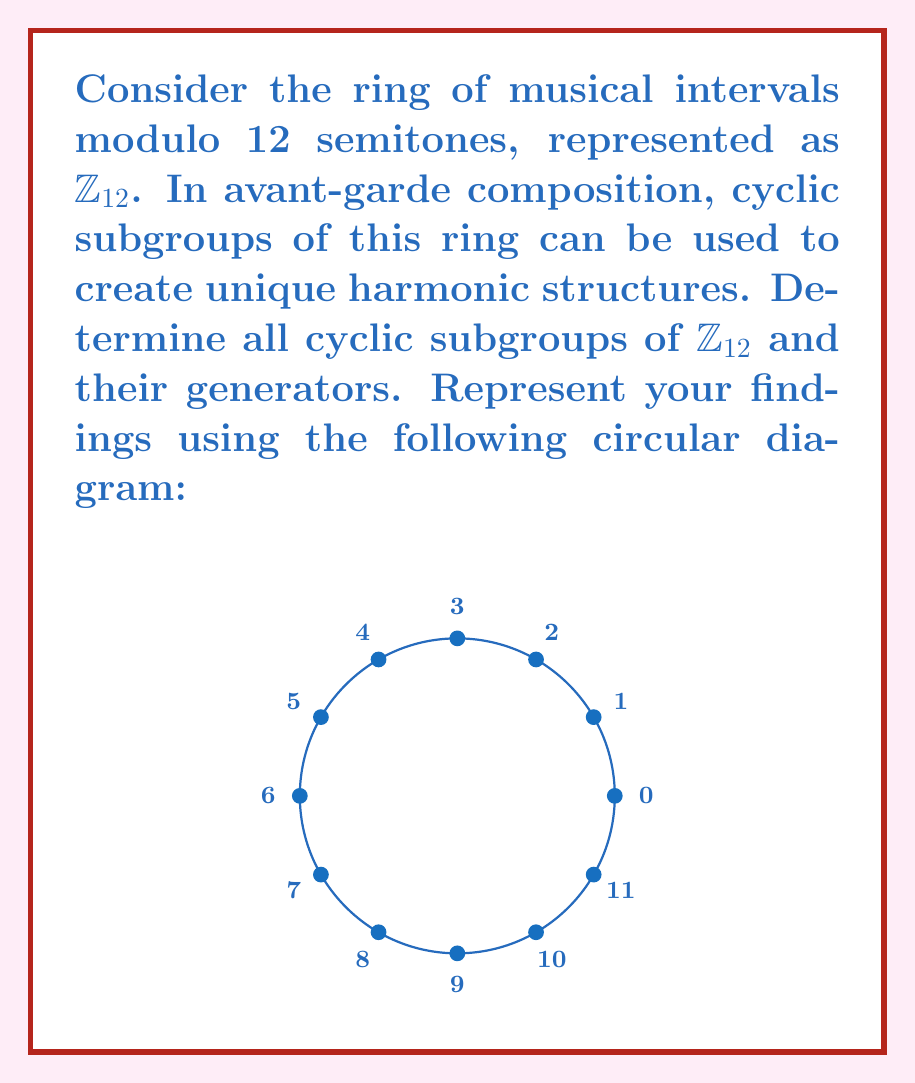Give your solution to this math problem. To find the cyclic subgroups of $\mathbb{Z}_{12}$, we need to consider each element and determine the subgroup it generates:

1) $\langle 0 \rangle = \{0\}$
2) $\langle 1 \rangle = \{0,1,2,3,4,5,6,7,8,9,10,11\} = \mathbb{Z}_{12}$
3) $\langle 2 \rangle = \{0,2,4,6,8,10\}$
4) $\langle 3 \rangle = \{0,3,6,9\}$
5) $\langle 4 \rangle = \{0,4,8\}$
6) $\langle 5 \rangle = \{0,1,2,3,4,5,6,7,8,9,10,11\} = \mathbb{Z}_{12}$
7) $\langle 6 \rangle = \{0,6\}$
8) $\langle 7 \rangle = \{0,1,2,3,4,5,6,7,8,9,10,11\} = \mathbb{Z}_{12}$
9) $\langle 8 \rangle = \{0,4,8\}$
10) $\langle 9 \rangle = \{0,3,6,9\}$
11) $\langle 10 \rangle = \{0,2,4,6,8,10\}$
12) $\langle 11 \rangle = \{0,1,2,3,4,5,6,7,8,9,10,11\} = \mathbb{Z}_{12}$

The unique cyclic subgroups are:
- $\{0\}$ (trivial subgroup)
- $\{0,6\}$
- $\{0,4,8\}$
- $\{0,3,6,9\}$
- $\{0,2,4,6,8,10\}$
- $\mathbb{Z}_{12}$

Generators for each subgroup:
- $\{0\}$: 0
- $\{0,6\}$: 6
- $\{0,4,8\}$: 4, 8
- $\{0,3,6,9\}$: 3, 9
- $\{0,2,4,6,8,10\}$: 2, 10
- $\mathbb{Z}_{12}$: 1, 5, 7, 11
Answer: Cyclic subgroups: $\{0\}$, $\{0,6\}$, $\{0,4,8\}$, $\{0,3,6,9\}$, $\{0,2,4,6,8,10\}$, $\mathbb{Z}_{12}$. Generators: 0; 6; 4,8; 3,9; 2,10; 1,5,7,11. 